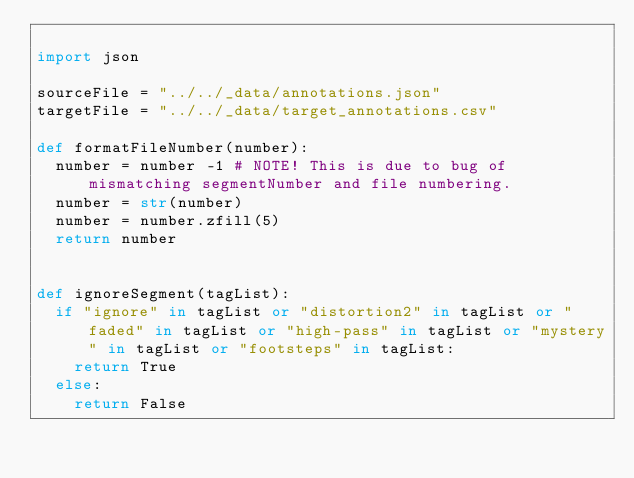<code> <loc_0><loc_0><loc_500><loc_500><_Python_>
import json

sourceFile = "../../_data/annotations.json"
targetFile = "../../_data/target_annotations.csv"

def formatFileNumber(number):
  number = number -1 # NOTE! This is due to bug of mismatching segmentNumber and file numbering.
  number = str(number)
  number = number.zfill(5)
  return number


def ignoreSegment(tagList):
  if "ignore" in tagList or "distortion2" in tagList or "faded" in tagList or "high-pass" in tagList or "mystery" in tagList or "footsteps" in tagList:
    return True
  else:
    return False

</code> 